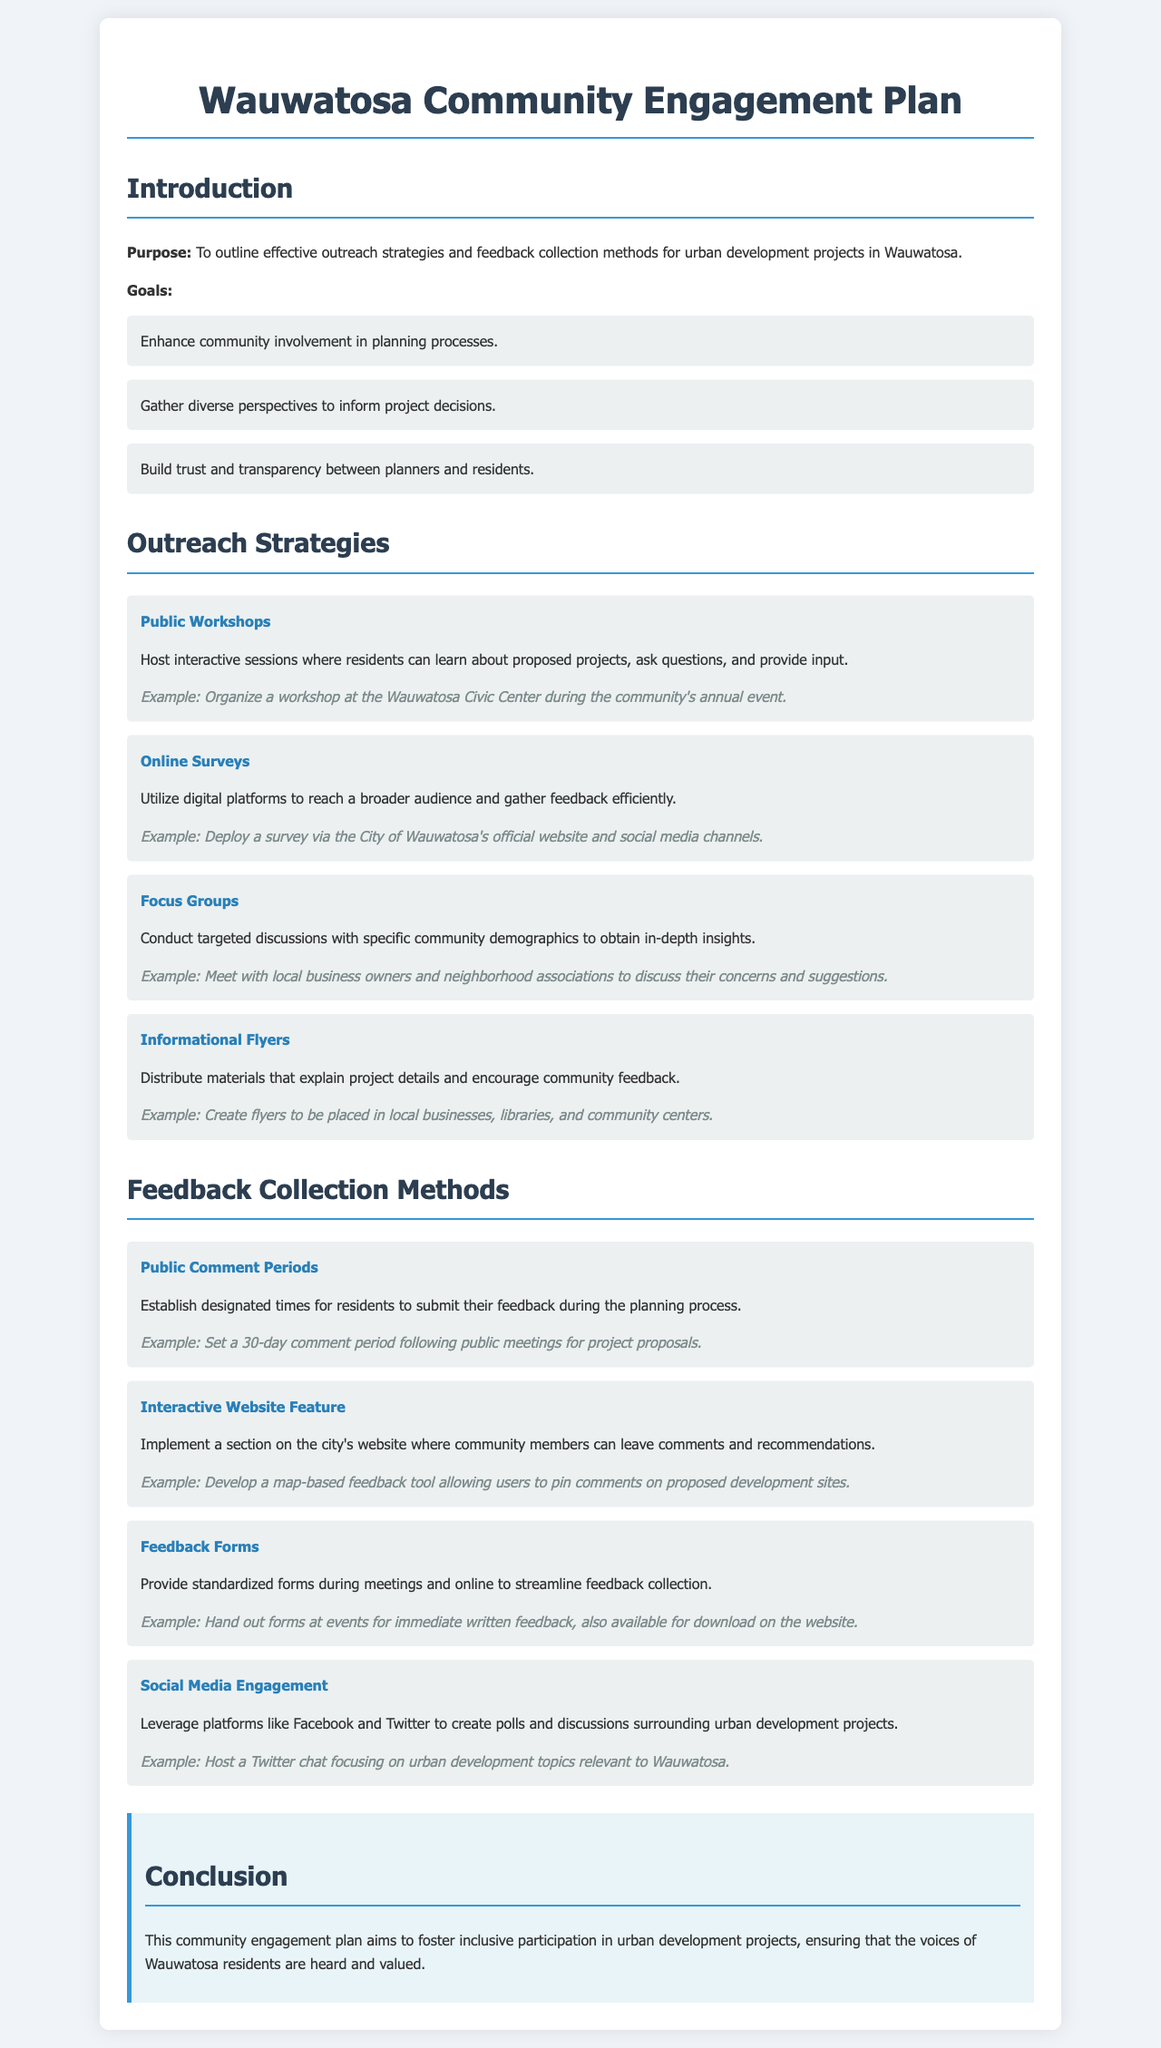what is the purpose of the Community Engagement Plan? The purpose of the plan is outlined in the introduction section, which states that it is to outline effective outreach strategies and feedback collection methods for urban development projects in Wauwatosa.
Answer: to outline effective outreach strategies and feedback collection methods what are the goals of the Community Engagement Plan? The goals are listed in a bullet format under the goals section, detailing three specific aims of the engagement plan.
Answer: Enhance community involvement in planning processes, Gather diverse perspectives to inform project decisions, Build trust and transparency between planners and residents how many outreach strategies are listed in the document? The document lists several outreach strategies in the respective section with a corresponding number of items.
Answer: Four name one feedback collection method mentioned in the document. The document provides multiple feedback collection methods in a list format, where one such method can be derived from the content.
Answer: Public Comment Periods which outreach strategy involves distributing materials? The strategy related to distributing materials is explicitly mentioned in the outreach strategies section regarding an action planners can take to inform the community.
Answer: Informational Flyers what is an example of an online survey strategy? The document includes an example under the online surveys outreach strategy, demonstrating how the strategy can be implemented effectively.
Answer: Deploy a survey via the City of Wauwatosa's official website and social media channels how long is the public comment period following public meetings? The duration of the public comment period is specifically mentioned in the feedback collection methods section as a follow-up action to public meetings.
Answer: 30 days what is one example of social media engagement mentioned? The document discusses social media engagement and provides a concrete example to illustrate how it can be executed in the context of urban development.
Answer: Host a Twitter chat focusing on urban development topics relevant to Wauwatosa 